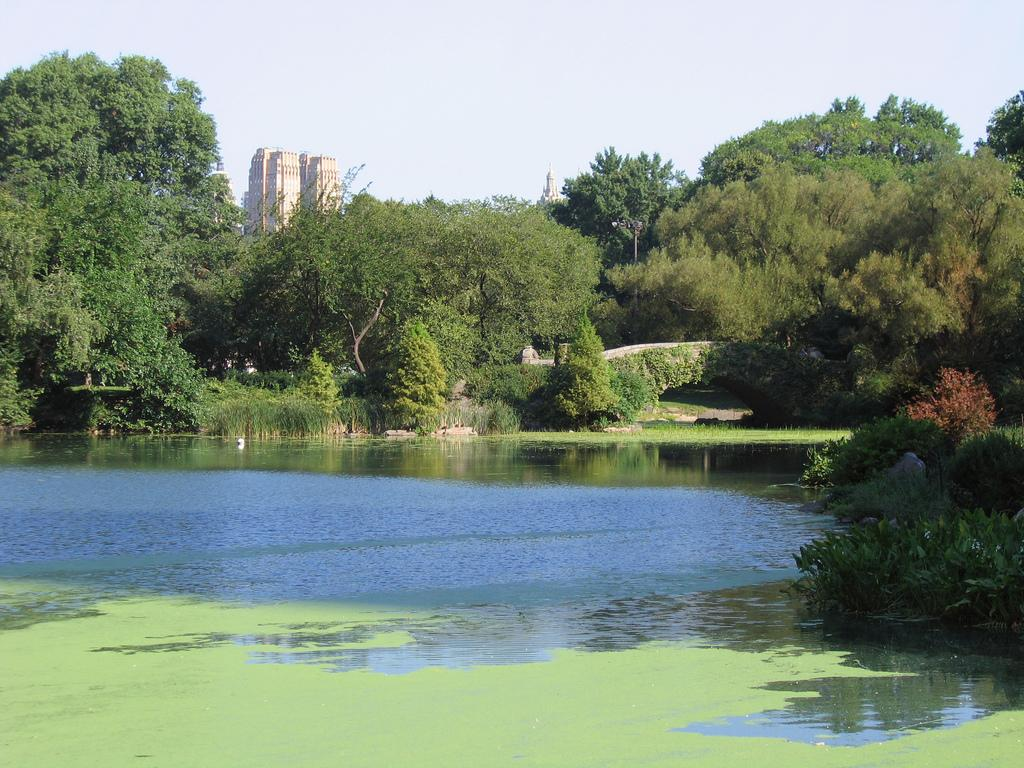What type of natural body of water is shown in the image? The image depicts a lake. What can be seen surrounding the lake? There are trees and plants around the lake. What is visible in the background of the image? There is a building and the sky in the background of the image. What type of noise can be heard coming from the calendar in the image? There is no calendar present in the image, and therefore no noise can be heard from it. 